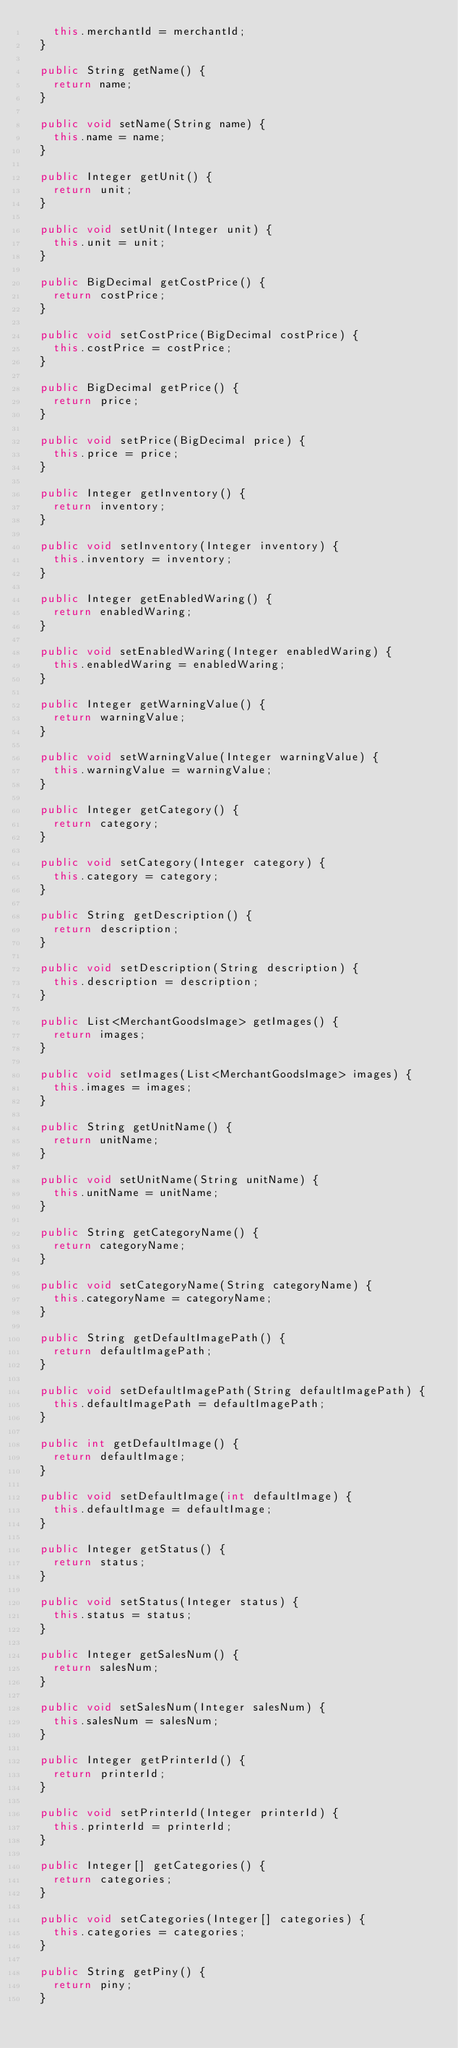<code> <loc_0><loc_0><loc_500><loc_500><_Java_>		this.merchantId = merchantId;
	}

	public String getName() {
		return name;
	}

	public void setName(String name) {
		this.name = name;
	}

	public Integer getUnit() {
		return unit;
	}

	public void setUnit(Integer unit) {
		this.unit = unit;
	}

	public BigDecimal getCostPrice() {
		return costPrice;
	}

	public void setCostPrice(BigDecimal costPrice) {
		this.costPrice = costPrice;
	}

	public BigDecimal getPrice() {
		return price;
	}

	public void setPrice(BigDecimal price) {
		this.price = price;
	}

	public Integer getInventory() {
		return inventory;
	}

	public void setInventory(Integer inventory) {
		this.inventory = inventory;
	}
	
	public Integer getEnabledWaring() {
		return enabledWaring;
	}

	public void setEnabledWaring(Integer enabledWaring) {
		this.enabledWaring = enabledWaring;
	}

	public Integer getWarningValue() {
		return warningValue;
	}

	public void setWarningValue(Integer warningValue) {
		this.warningValue = warningValue;
	}

	public Integer getCategory() {
		return category;
	}

	public void setCategory(Integer category) {
		this.category = category;
	}

	public String getDescription() {
		return description;
	}

	public void setDescription(String description) {
		this.description = description;
	}

	public List<MerchantGoodsImage> getImages() {
		return images;
	}

	public void setImages(List<MerchantGoodsImage> images) {
		this.images = images;
	}

	public String getUnitName() {
		return unitName;
	}

	public void setUnitName(String unitName) {
		this.unitName = unitName;
	}

	public String getCategoryName() {
		return categoryName;
	}

	public void setCategoryName(String categoryName) {
		this.categoryName = categoryName;
	}

	public String getDefaultImagePath() {
		return defaultImagePath;
	}

	public void setDefaultImagePath(String defaultImagePath) {
		this.defaultImagePath = defaultImagePath;
	}

	public int getDefaultImage() {
		return defaultImage;
	}

	public void setDefaultImage(int defaultImage) {
		this.defaultImage = defaultImage;
	}

	public Integer getStatus() {
		return status;
	}

	public void setStatus(Integer status) {
		this.status = status;
	}

	public Integer getSalesNum() {
		return salesNum;
	}

	public void setSalesNum(Integer salesNum) {
		this.salesNum = salesNum;
	}
	
	public Integer getPrinterId() {
		return printerId;
	}

	public void setPrinterId(Integer printerId) {
		this.printerId = printerId;
	}

	public Integer[] getCategories() {
		return categories;
	}

	public void setCategories(Integer[] categories) {
		this.categories = categories;
	}

	public String getPiny() {
		return piny;
	}
</code> 